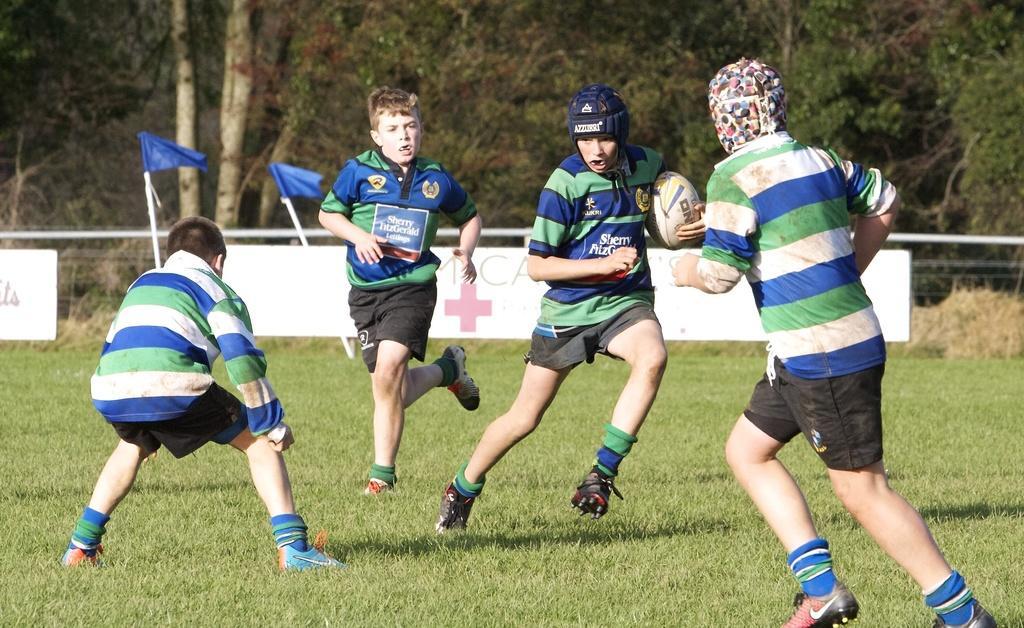Please provide a concise description of this image. In this picture we can see there is a group of people of people playing on the grass path and a person is holding a ball. Behind the people there are sticks with flags, trees and a board. 